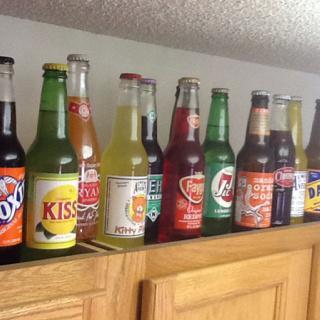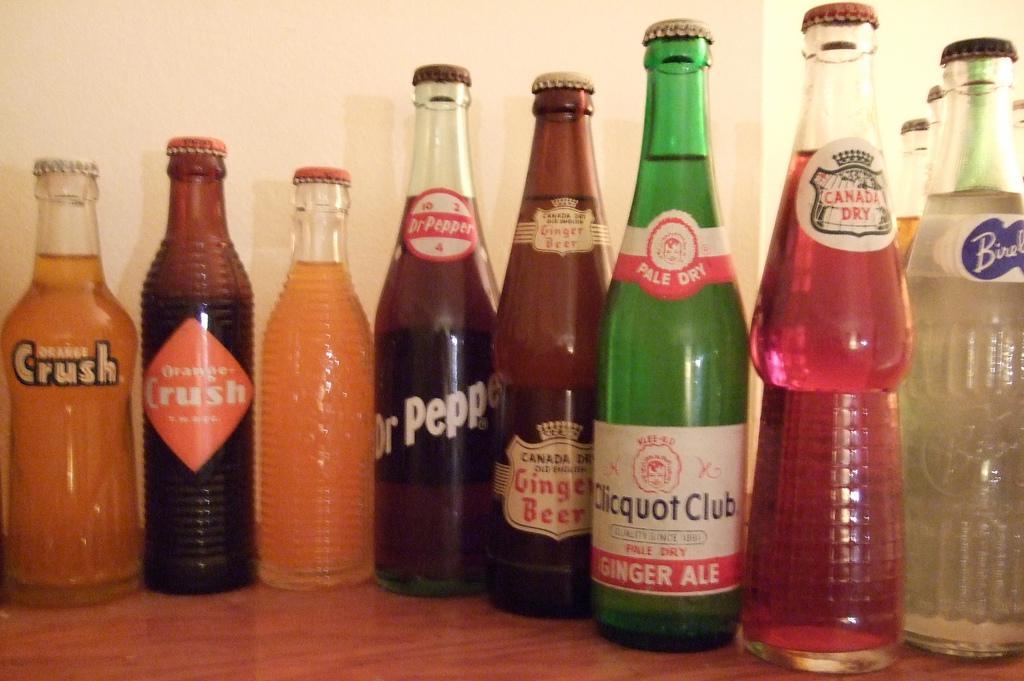The first image is the image on the left, the second image is the image on the right. Considering the images on both sides, is "There are empty bottles sitting on a shelf." valid? Answer yes or no. No. The first image is the image on the left, the second image is the image on the right. Given the left and right images, does the statement "All the bottles in these images are unopened and full of a beverage." hold true? Answer yes or no. Yes. 